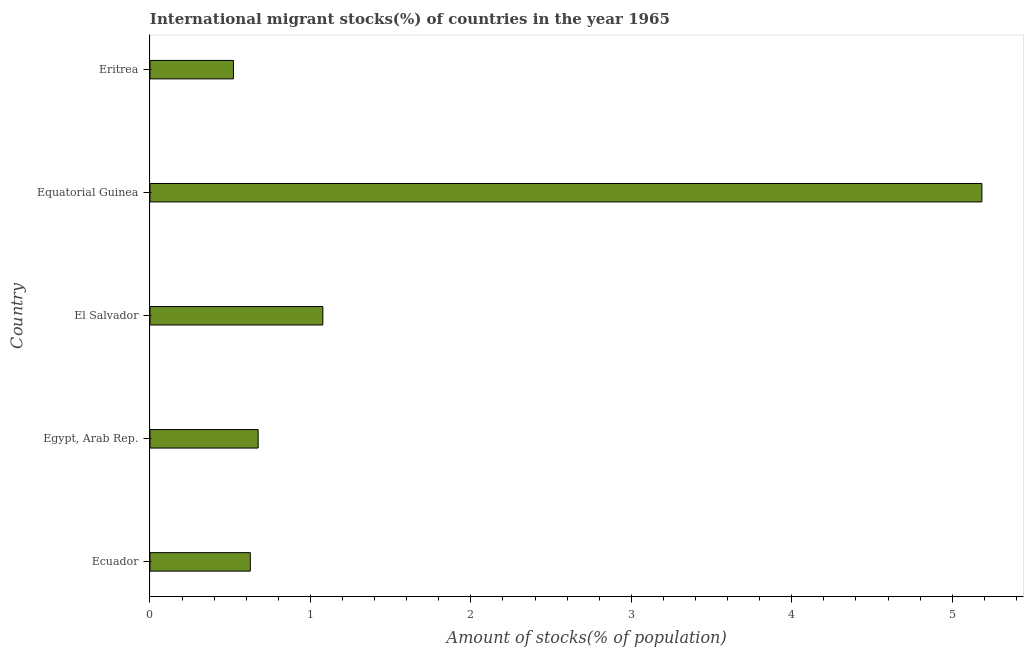What is the title of the graph?
Offer a terse response. International migrant stocks(%) of countries in the year 1965. What is the label or title of the X-axis?
Offer a very short reply. Amount of stocks(% of population). What is the number of international migrant stocks in Ecuador?
Ensure brevity in your answer.  0.63. Across all countries, what is the maximum number of international migrant stocks?
Your answer should be compact. 5.19. Across all countries, what is the minimum number of international migrant stocks?
Your response must be concise. 0.52. In which country was the number of international migrant stocks maximum?
Your answer should be very brief. Equatorial Guinea. In which country was the number of international migrant stocks minimum?
Make the answer very short. Eritrea. What is the sum of the number of international migrant stocks?
Ensure brevity in your answer.  8.08. What is the difference between the number of international migrant stocks in Ecuador and Egypt, Arab Rep.?
Your response must be concise. -0.05. What is the average number of international migrant stocks per country?
Offer a very short reply. 1.62. What is the median number of international migrant stocks?
Your response must be concise. 0.67. What is the ratio of the number of international migrant stocks in Egypt, Arab Rep. to that in Equatorial Guinea?
Provide a succinct answer. 0.13. Is the number of international migrant stocks in Egypt, Arab Rep. less than that in Equatorial Guinea?
Ensure brevity in your answer.  Yes. Is the difference between the number of international migrant stocks in Ecuador and Egypt, Arab Rep. greater than the difference between any two countries?
Keep it short and to the point. No. What is the difference between the highest and the second highest number of international migrant stocks?
Make the answer very short. 4.11. What is the difference between the highest and the lowest number of international migrant stocks?
Give a very brief answer. 4.66. In how many countries, is the number of international migrant stocks greater than the average number of international migrant stocks taken over all countries?
Offer a terse response. 1. How many bars are there?
Give a very brief answer. 5. What is the difference between two consecutive major ticks on the X-axis?
Your answer should be compact. 1. What is the Amount of stocks(% of population) in Ecuador?
Your answer should be very brief. 0.63. What is the Amount of stocks(% of population) of Egypt, Arab Rep.?
Give a very brief answer. 0.67. What is the Amount of stocks(% of population) in El Salvador?
Make the answer very short. 1.08. What is the Amount of stocks(% of population) in Equatorial Guinea?
Offer a terse response. 5.19. What is the Amount of stocks(% of population) in Eritrea?
Provide a succinct answer. 0.52. What is the difference between the Amount of stocks(% of population) in Ecuador and Egypt, Arab Rep.?
Keep it short and to the point. -0.05. What is the difference between the Amount of stocks(% of population) in Ecuador and El Salvador?
Your answer should be very brief. -0.45. What is the difference between the Amount of stocks(% of population) in Ecuador and Equatorial Guinea?
Provide a short and direct response. -4.56. What is the difference between the Amount of stocks(% of population) in Ecuador and Eritrea?
Offer a very short reply. 0.11. What is the difference between the Amount of stocks(% of population) in Egypt, Arab Rep. and El Salvador?
Your answer should be compact. -0.4. What is the difference between the Amount of stocks(% of population) in Egypt, Arab Rep. and Equatorial Guinea?
Offer a very short reply. -4.51. What is the difference between the Amount of stocks(% of population) in Egypt, Arab Rep. and Eritrea?
Offer a very short reply. 0.15. What is the difference between the Amount of stocks(% of population) in El Salvador and Equatorial Guinea?
Provide a short and direct response. -4.11. What is the difference between the Amount of stocks(% of population) in El Salvador and Eritrea?
Your answer should be very brief. 0.56. What is the difference between the Amount of stocks(% of population) in Equatorial Guinea and Eritrea?
Offer a terse response. 4.66. What is the ratio of the Amount of stocks(% of population) in Ecuador to that in Egypt, Arab Rep.?
Provide a succinct answer. 0.93. What is the ratio of the Amount of stocks(% of population) in Ecuador to that in El Salvador?
Provide a succinct answer. 0.58. What is the ratio of the Amount of stocks(% of population) in Ecuador to that in Equatorial Guinea?
Provide a succinct answer. 0.12. What is the ratio of the Amount of stocks(% of population) in Ecuador to that in Eritrea?
Your response must be concise. 1.2. What is the ratio of the Amount of stocks(% of population) in Egypt, Arab Rep. to that in El Salvador?
Your answer should be very brief. 0.63. What is the ratio of the Amount of stocks(% of population) in Egypt, Arab Rep. to that in Equatorial Guinea?
Your answer should be compact. 0.13. What is the ratio of the Amount of stocks(% of population) in Egypt, Arab Rep. to that in Eritrea?
Provide a short and direct response. 1.3. What is the ratio of the Amount of stocks(% of population) in El Salvador to that in Equatorial Guinea?
Your response must be concise. 0.21. What is the ratio of the Amount of stocks(% of population) in El Salvador to that in Eritrea?
Your response must be concise. 2.07. What is the ratio of the Amount of stocks(% of population) in Equatorial Guinea to that in Eritrea?
Offer a terse response. 9.97. 